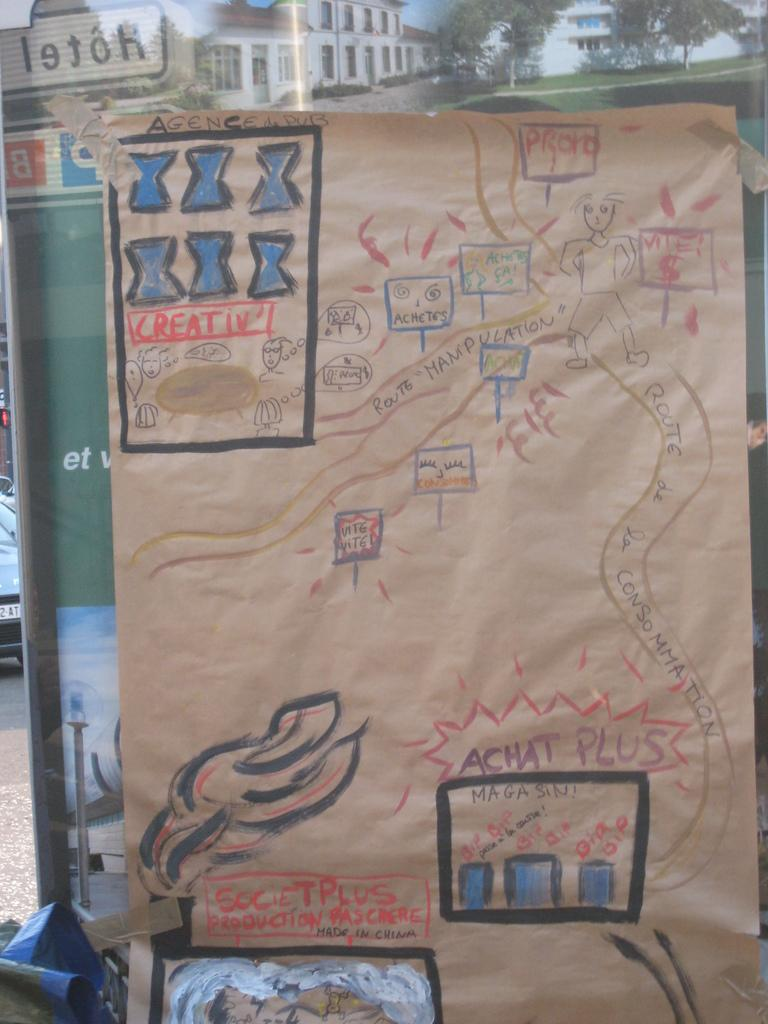<image>
Describe the image concisely. A drawing on brown paper displays the phrase "achat plus" in purple letters. 